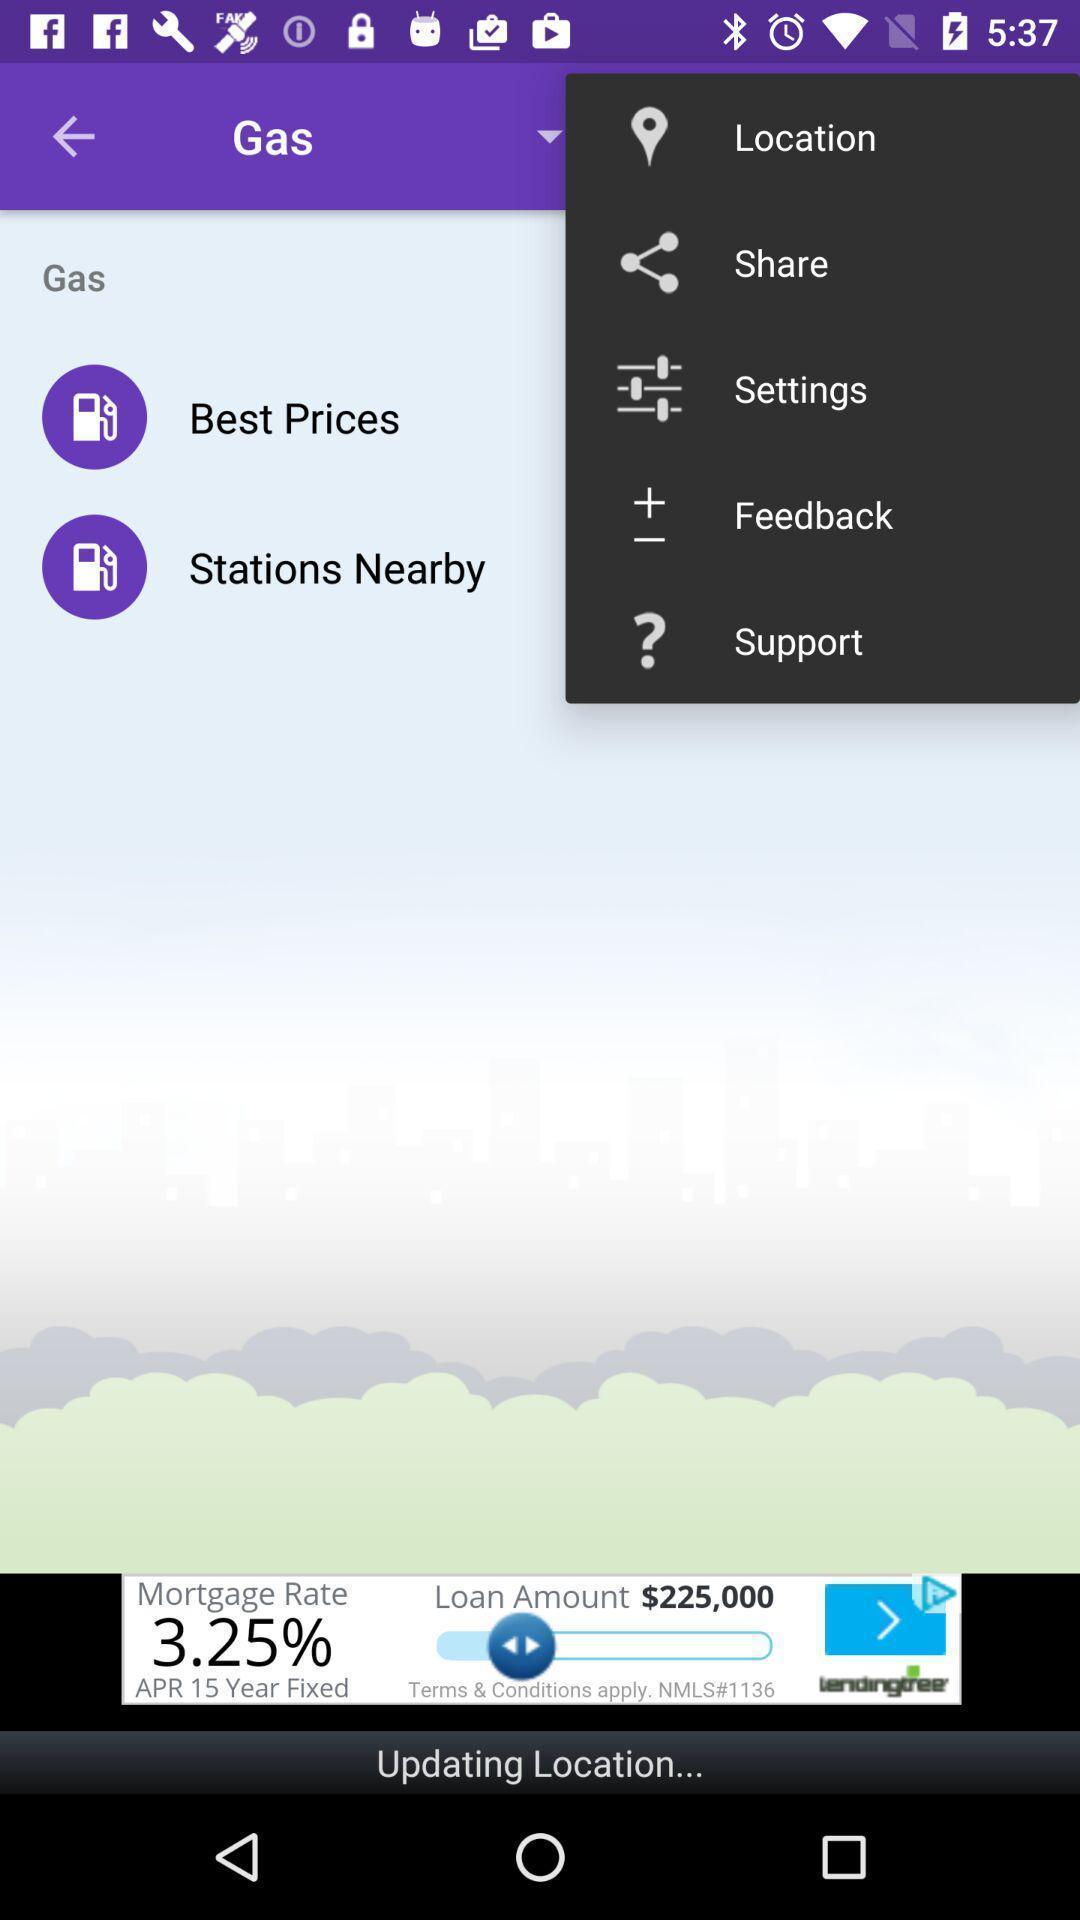Please provide a description for this image. Pop up showing multiple options. 